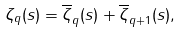<formula> <loc_0><loc_0><loc_500><loc_500>\zeta _ { q } ( s ) = \overline { \zeta } _ { q } ( s ) + \overline { \zeta } _ { q + 1 } ( s ) ,</formula> 